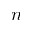<formula> <loc_0><loc_0><loc_500><loc_500>n</formula> 